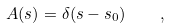<formula> <loc_0><loc_0><loc_500><loc_500>A ( s ) = \delta ( s - s _ { 0 } ) \quad ,</formula> 